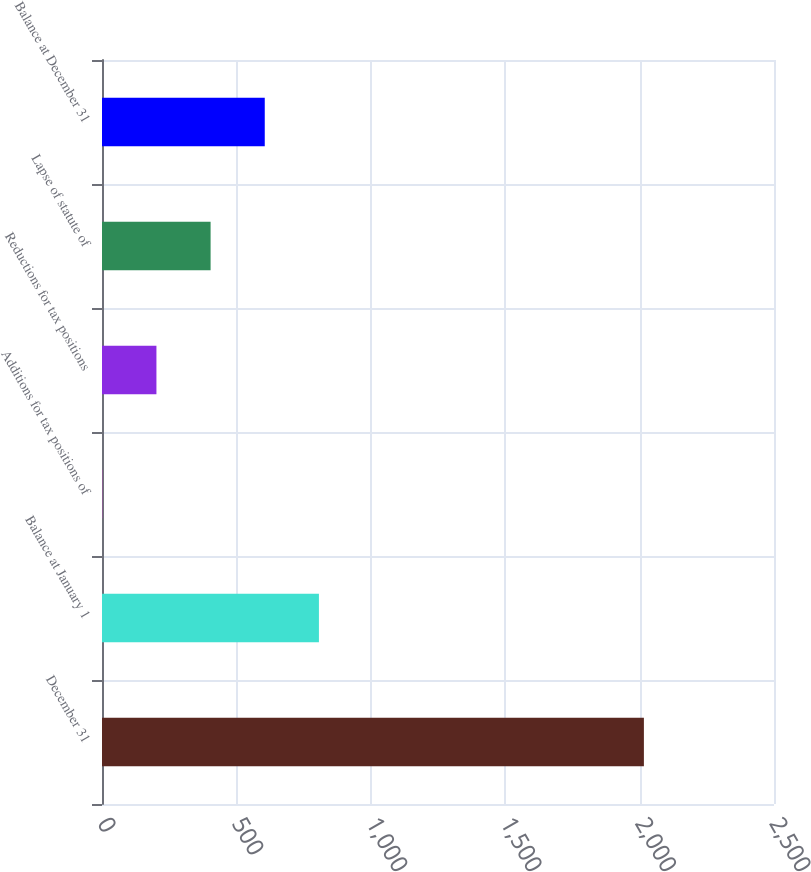Convert chart to OTSL. <chart><loc_0><loc_0><loc_500><loc_500><bar_chart><fcel>December 31<fcel>Balance at January 1<fcel>Additions for tax positions of<fcel>Reductions for tax positions<fcel>Lapse of statute of<fcel>Balance at December 31<nl><fcel>2016<fcel>807<fcel>1<fcel>202.5<fcel>404<fcel>605.5<nl></chart> 